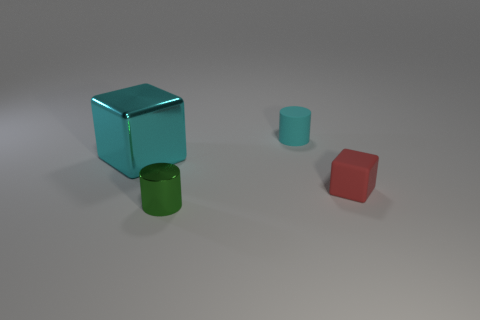Subtract 1 cylinders. How many cylinders are left? 1 Subtract all green cylinders. How many yellow blocks are left? 0 Subtract all tiny red spheres. Subtract all big cyan shiny things. How many objects are left? 3 Add 4 metal cylinders. How many metal cylinders are left? 5 Add 1 cyan rubber cylinders. How many cyan rubber cylinders exist? 2 Add 1 blocks. How many objects exist? 5 Subtract 1 cyan cubes. How many objects are left? 3 Subtract all cyan cylinders. Subtract all blue cubes. How many cylinders are left? 1 